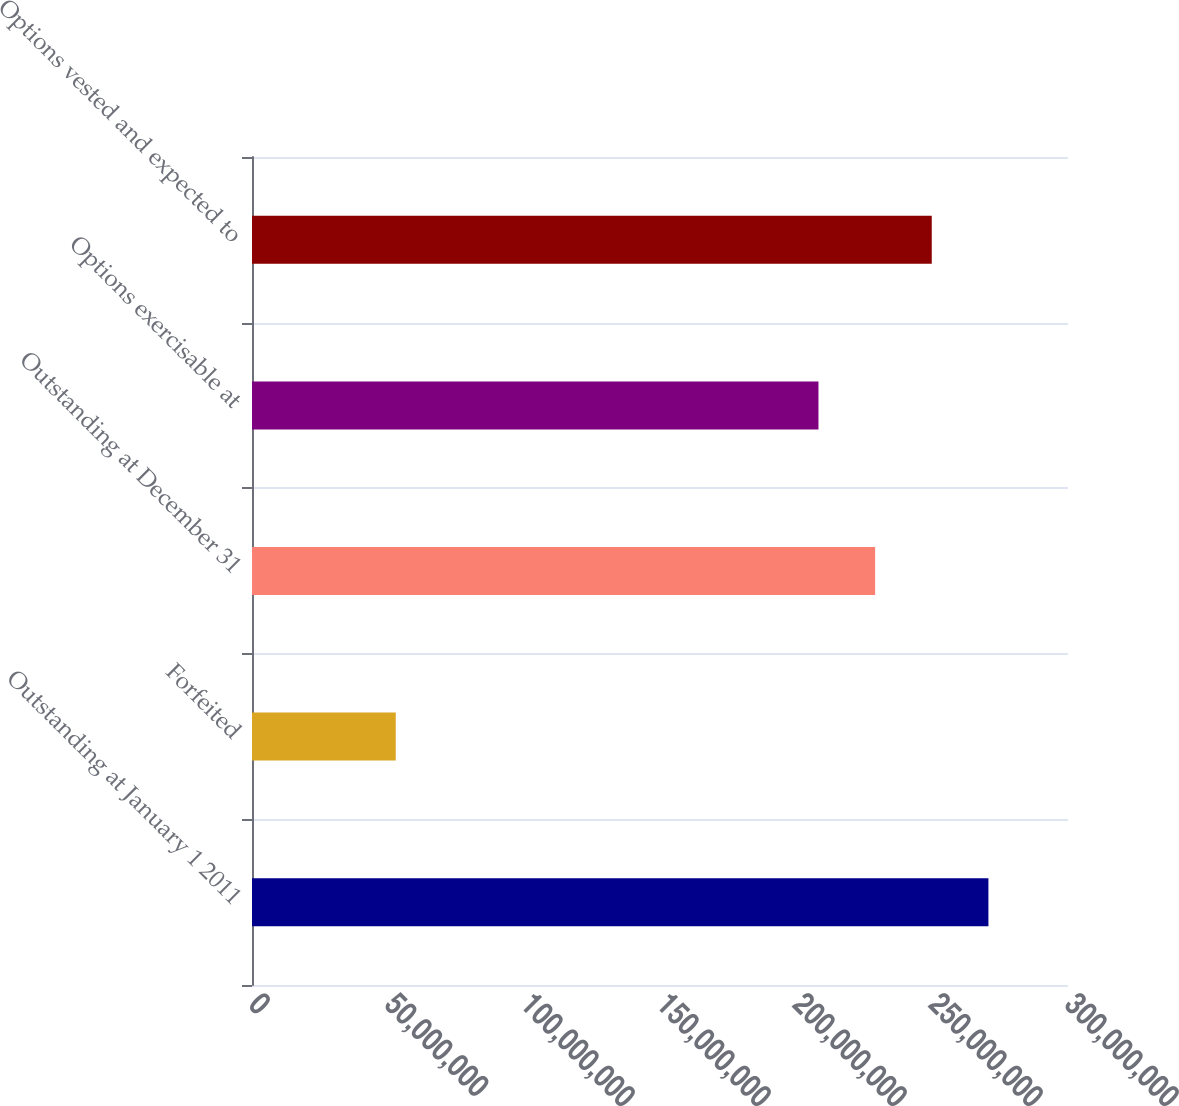Convert chart to OTSL. <chart><loc_0><loc_0><loc_500><loc_500><bar_chart><fcel>Outstanding at January 1 2011<fcel>Forfeited<fcel>Outstanding at December 31<fcel>Options exercisable at<fcel>Options vested and expected to<nl><fcel>2.7074e+08<fcel>5.28533e+07<fcel>2.29086e+08<fcel>2.08259e+08<fcel>2.49913e+08<nl></chart> 